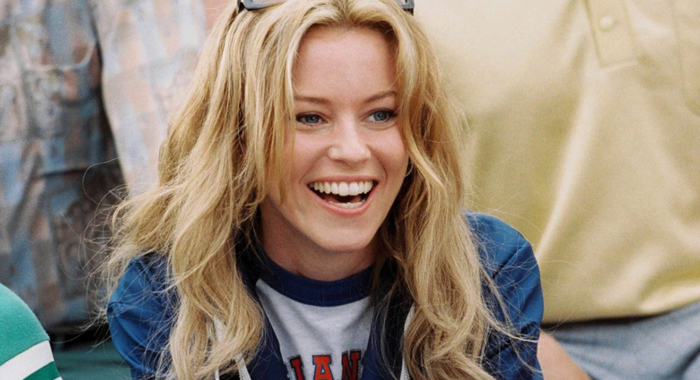What might the 'LA' on her shirt represent in this context? The 'LA' on her shirt likely stands for Los Angeles, which could indicate that she is a fan of a sports team from that city or it could be a fashionable representation of the city itself. It sets a relaxed, urban theme. 